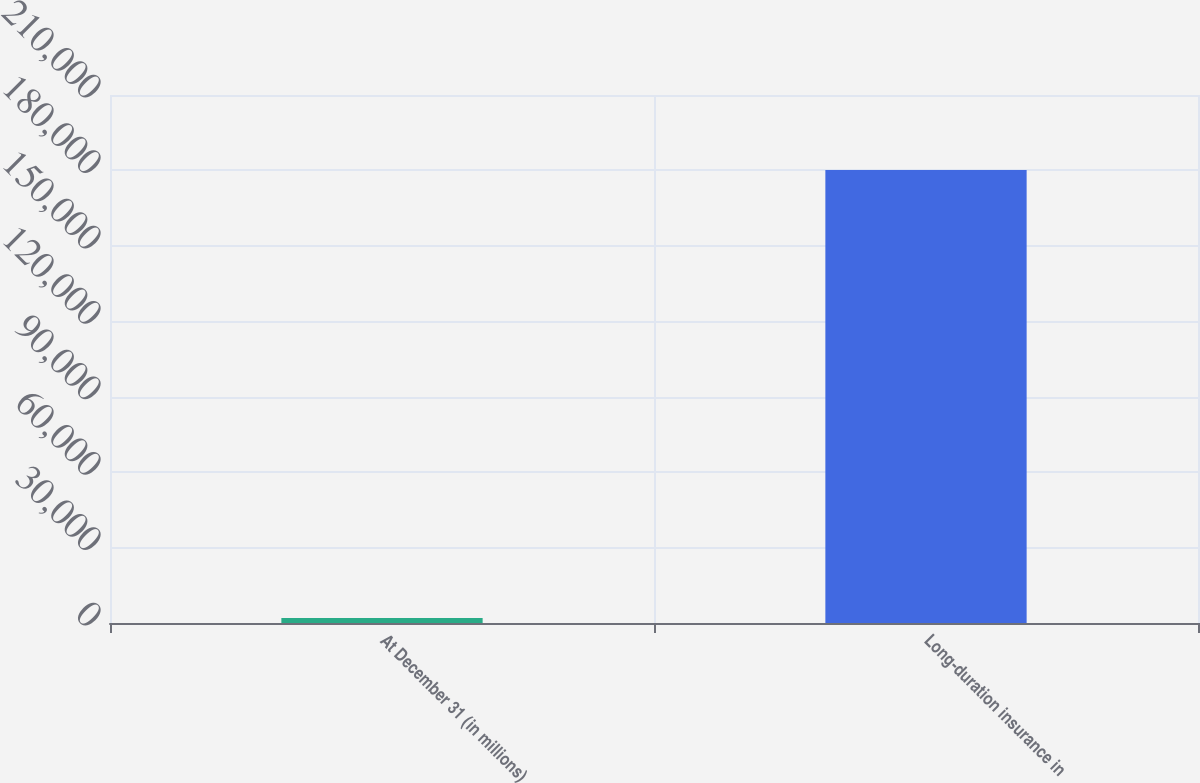Convert chart to OTSL. <chart><loc_0><loc_0><loc_500><loc_500><bar_chart><fcel>At December 31 (in millions)<fcel>Long-duration insurance in<nl><fcel>2014<fcel>180178<nl></chart> 